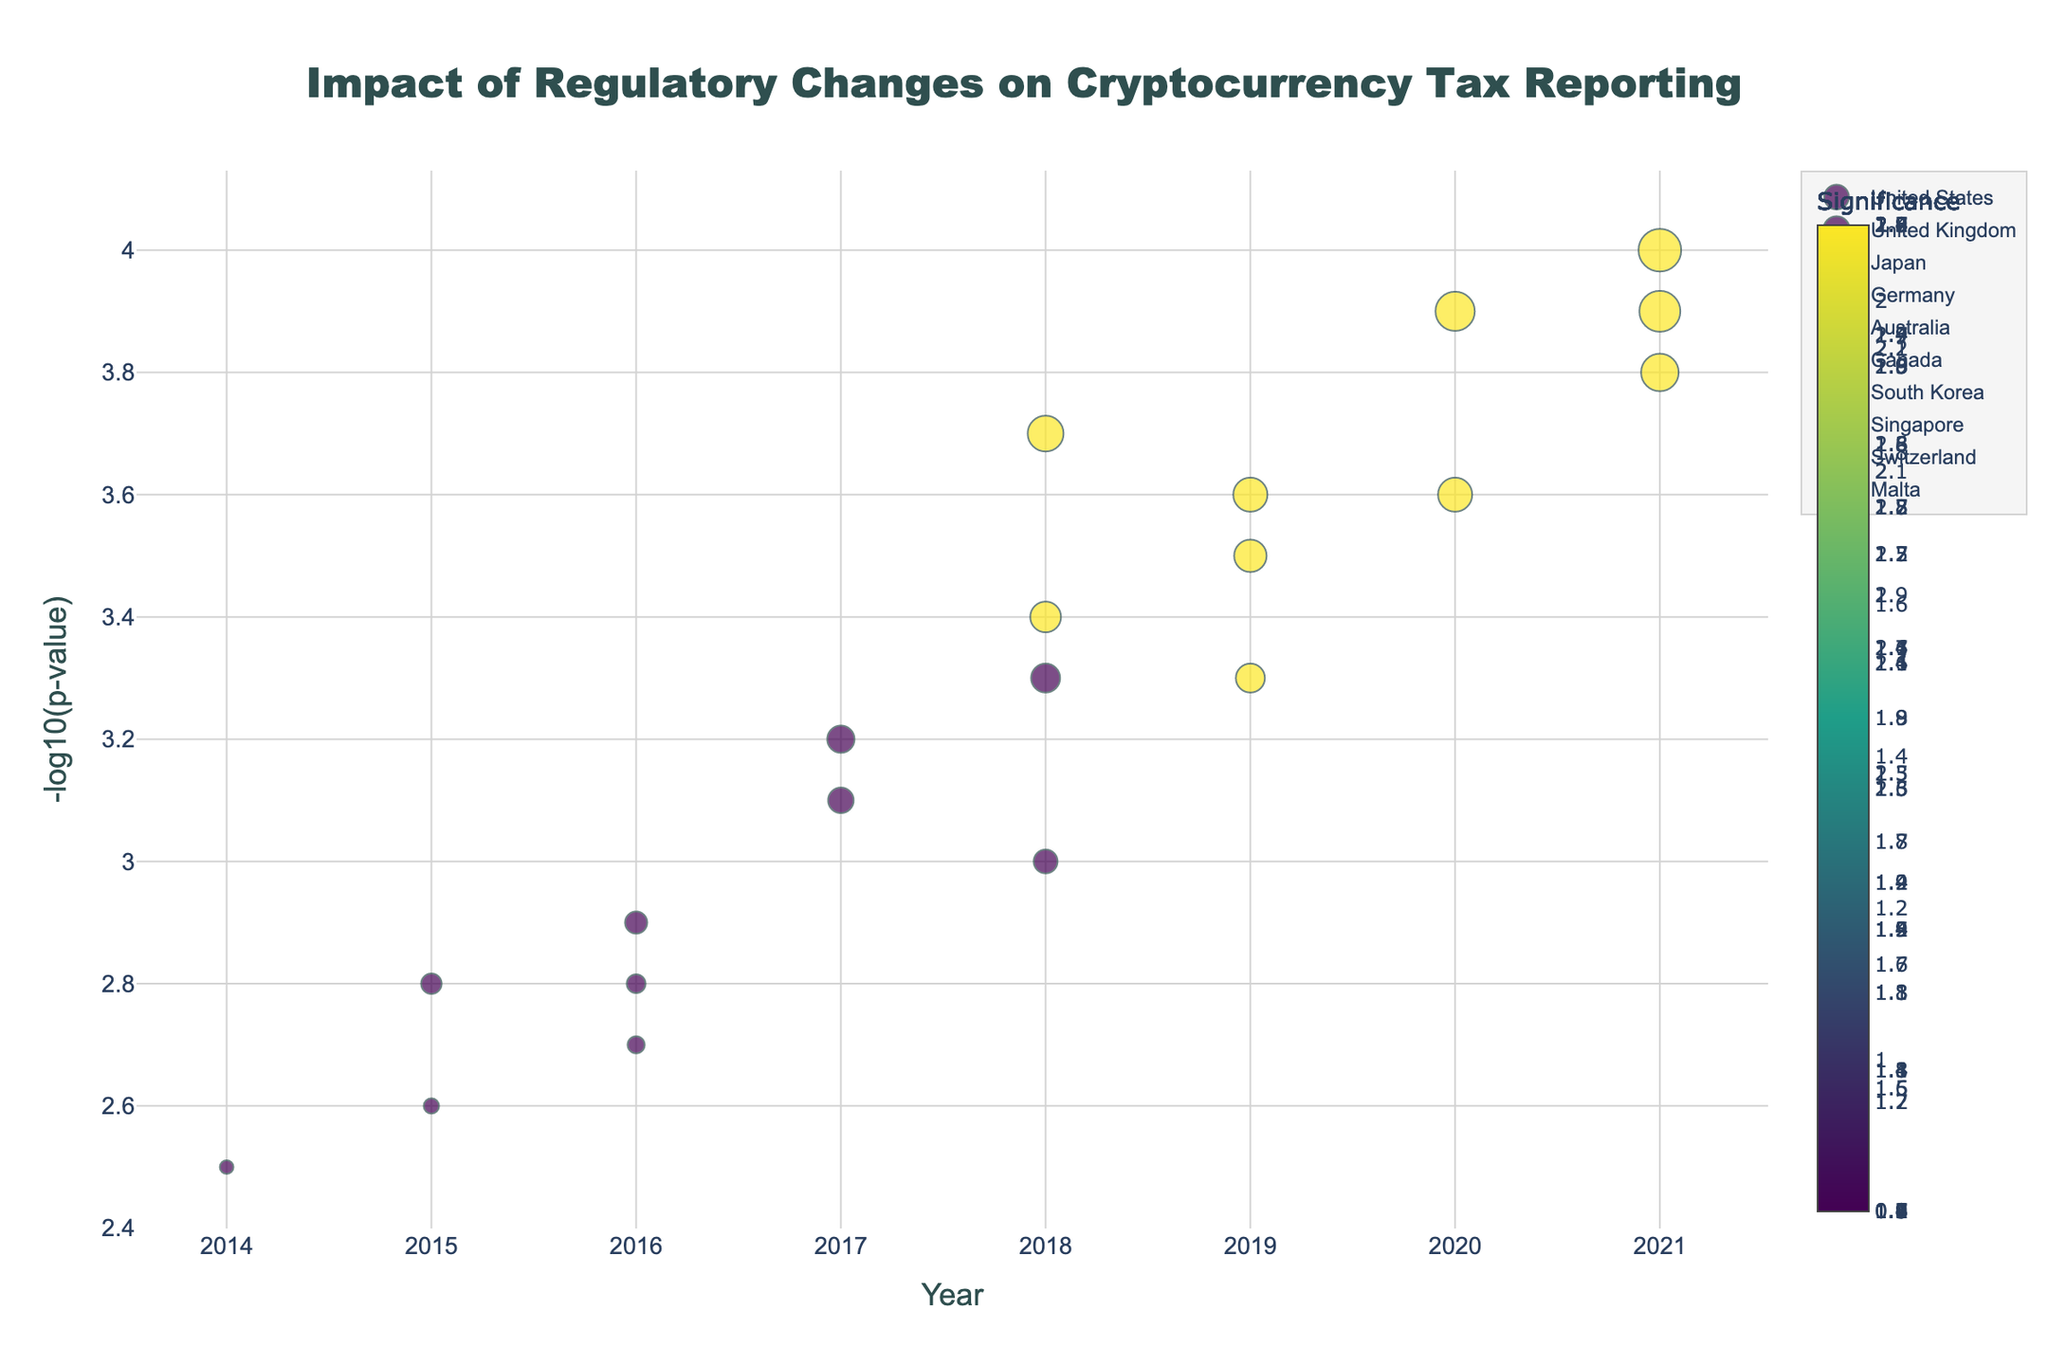What is the title of the plot? The title of the plot is given at the top and usually summarizes the content and purpose of the plot.
Answer: Impact of Regulatory Changes on Cryptocurrency Tax Reporting Which country had the highest significance in 2021? To find the highest significance in 2021, look for the data point in 2021 with the largest marker size. Since South Korea in 2021 has the largest size, indicating the highest significance.
Answer: South Korea How does the -log10(p-value) of Japan compare between 2017 and 2020? Compare the y-axis values for Japan in 2017 and 2020; in 2017 it is 3.1, and in 2020 it is 3.9.
Answer: 2020 is higher than 2017 Which country has the most visible change in significance between 2018 and 2021? To identify the most visible change, evaluate the change in marker sizes between 2018 and 2021 for each country. Malta's significance increased from 1.7 in 2018 to 2.4 in 2021, the largest increase among other countries listed.
Answer: Malta What is the smallest -log10(p-value) value shown in the plot, and which country/year does it correspond to? The smallest -log10(p-value) is the lowest on the y-axis. The lowest value is 2.5, which corresponds to the United States in 2014.
Answer: 2.5, United States, 2014 Between which years did the United States see an increase in significance? Look for the progression of marker sizes for the United States. From 2014 (0.8) to 2018 (2.1).
Answer: Between 2014 and 2018 Compare the significance values of Germany in 2016 and Canada in 2016. Which is higher? Compare the marker sizes for Germany and Canada in 2016. Germany has a significance of 1.0 and Canada 1.1.
Answer: Canada What pattern can you observe in the -log10(p-value) for the United Kingdom from 2015 to 2019? Observe the trend on the y-axis for the United Kingdom. The values go from 2.8 in 2015 to 3.5 in 2019, indicating an increase in -log10(p-value).
Answer: Increasing trend How does the significance of Singapore in 2021 compare to its significance in 2018? Look at the marker sizes for Singapore in 2021 and 2018. In 2018 the significance is 1.4, and in 2021 it is 2.2.
Answer: 2021 is higher than 2018 Which year had the highest visible marker size for Malta, and what does this indicate? Observe the marker size for Malta over the years; 2021 has the highest size, indicating the highest significance.
Answer: 2021 